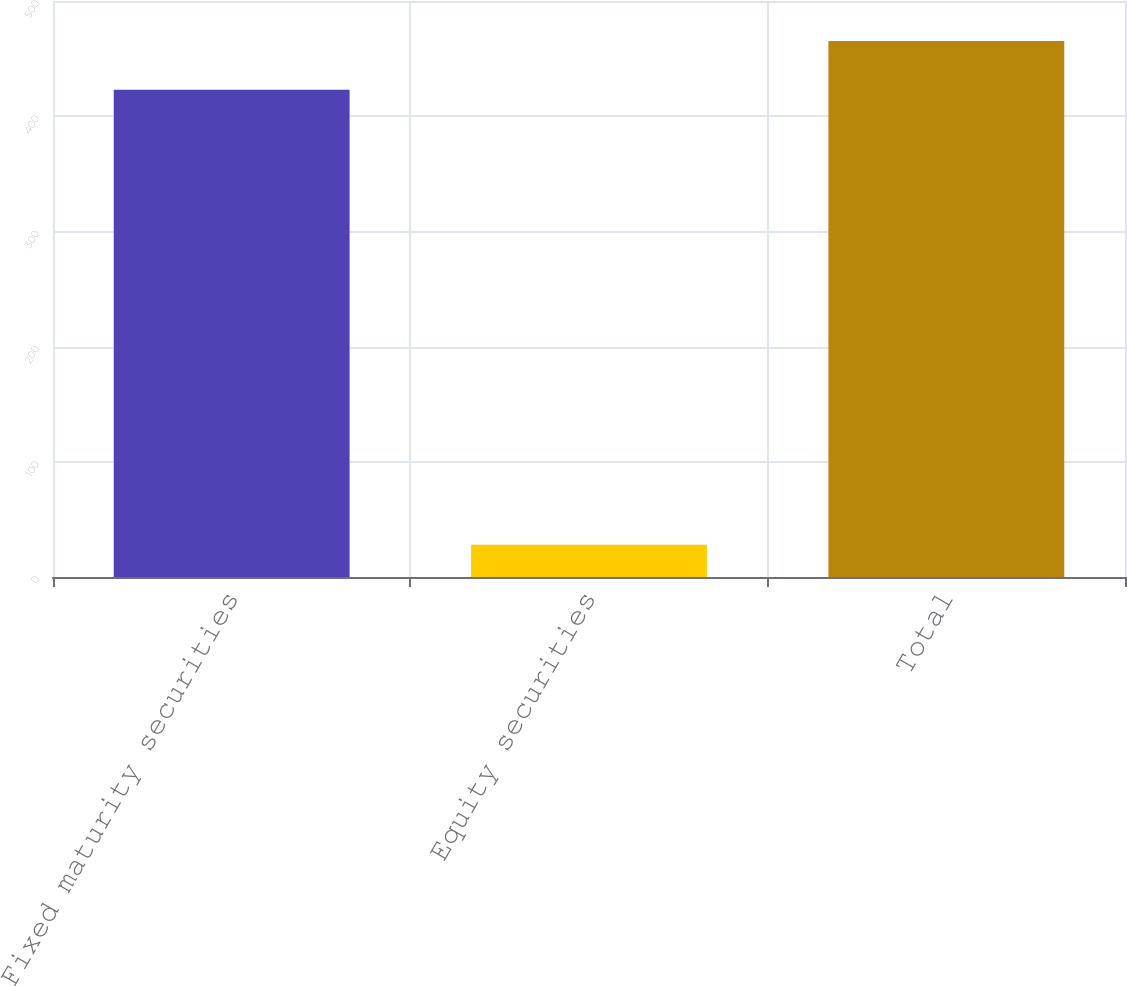Convert chart. <chart><loc_0><loc_0><loc_500><loc_500><bar_chart><fcel>Fixed maturity securities<fcel>Equity securities<fcel>Total<nl><fcel>423<fcel>28<fcel>465.3<nl></chart> 